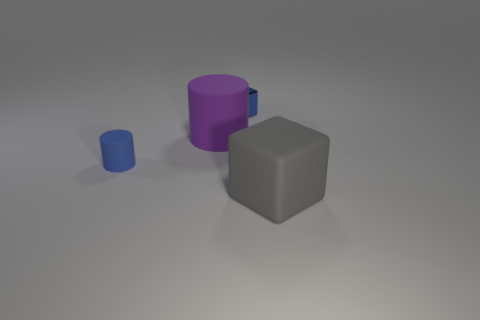Add 4 brown rubber things. How many objects exist? 8 Add 3 blue things. How many blue things exist? 5 Subtract 0 brown balls. How many objects are left? 4 Subtract all small rubber cylinders. Subtract all tiny cubes. How many objects are left? 2 Add 3 large rubber objects. How many large rubber objects are left? 5 